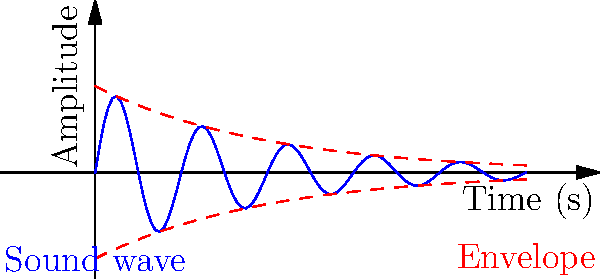In an empty Victorian theater, a melancholic soliloquy echoes through the hall. The graph depicts the decay of sound waves over time. If the amplitude $A$ at time $t$ is given by $A(t) = A_0 e^{-\beta t} \sin(2\pi f t)$, where $A_0$ is the initial amplitude, $\beta$ is the decay constant, and $f$ is the frequency, what does $\beta$ represent in the context of fading memories? To understand the role of $\beta$ in the context of fading memories, let's analyze the equation step-by-step:

1. The equation $A(t) = A_0 e^{-\beta t} \sin(2\pi f t)$ represents a damped sinusoidal wave.

2. $A_0$ is the initial amplitude, representing the original intensity of the memory.

3. $\sin(2\pi f t)$ represents the oscillating nature of the sound wave, or the cyclical nature of memory recall.

4. The crucial part for our analysis is $e^{-\beta t}$, which is the exponential decay factor.

5. As time $t$ increases, $e^{-\beta t}$ decreases, causing the amplitude to diminish over time.

6. $\beta$ is the decay constant, determining how quickly the amplitude (or memory intensity) fades.

7. A larger $\beta$ value results in faster decay, while a smaller $\beta$ value leads to slower decay.

8. In the context of memories, $\beta$ represents the rate at which memories fade or lose their emotional intensity over time.

9. Just as the sound waves in the empty theater gradually diminish, our memories become less vivid and emotionally charged as time passes.

Therefore, $\beta$ symbolizes the rate of memory decay or the speed at which the emotional impact of memories diminishes over time.
Answer: Rate of memory decay 